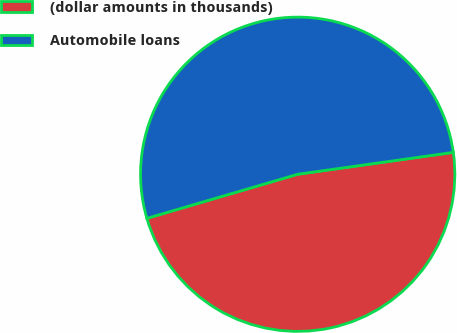Convert chart. <chart><loc_0><loc_0><loc_500><loc_500><pie_chart><fcel>(dollar amounts in thousands)<fcel>Automobile loans<nl><fcel>47.7%<fcel>52.3%<nl></chart> 